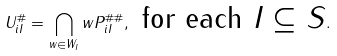Convert formula to latex. <formula><loc_0><loc_0><loc_500><loc_500>U _ { i I } ^ { \# } = \bigcap _ { w \in W _ { I } } w P _ { i I } ^ { \# \# } , \text { for each $I\subseteq S$} .</formula> 